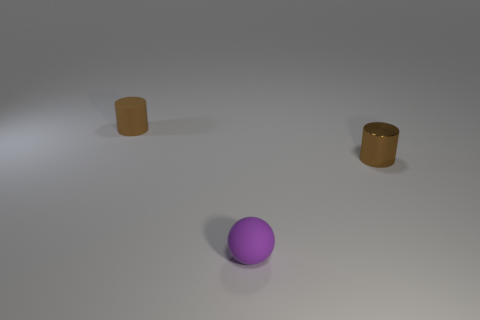What size is the rubber cylinder that is the same color as the shiny cylinder?
Provide a short and direct response. Small. What number of big objects are blue matte blocks or purple things?
Keep it short and to the point. 0. How many big green matte blocks are there?
Keep it short and to the point. 0. Is the number of small shiny cylinders on the left side of the purple matte thing the same as the number of purple rubber objects that are right of the brown shiny cylinder?
Give a very brief answer. Yes. Are there any brown shiny objects in front of the tiny metallic cylinder?
Give a very brief answer. No. What is the color of the cylinder to the right of the purple rubber thing?
Your answer should be very brief. Brown. What is the material of the brown cylinder behind the brown thing that is on the right side of the small brown matte thing?
Provide a short and direct response. Rubber. Is the number of tiny brown things behind the tiny purple matte object less than the number of small spheres that are behind the shiny object?
Provide a succinct answer. No. How many yellow objects are either tiny objects or small matte objects?
Ensure brevity in your answer.  0. Is the number of tiny brown metal cylinders that are to the right of the small brown metallic object the same as the number of small brown shiny things?
Make the answer very short. No. 